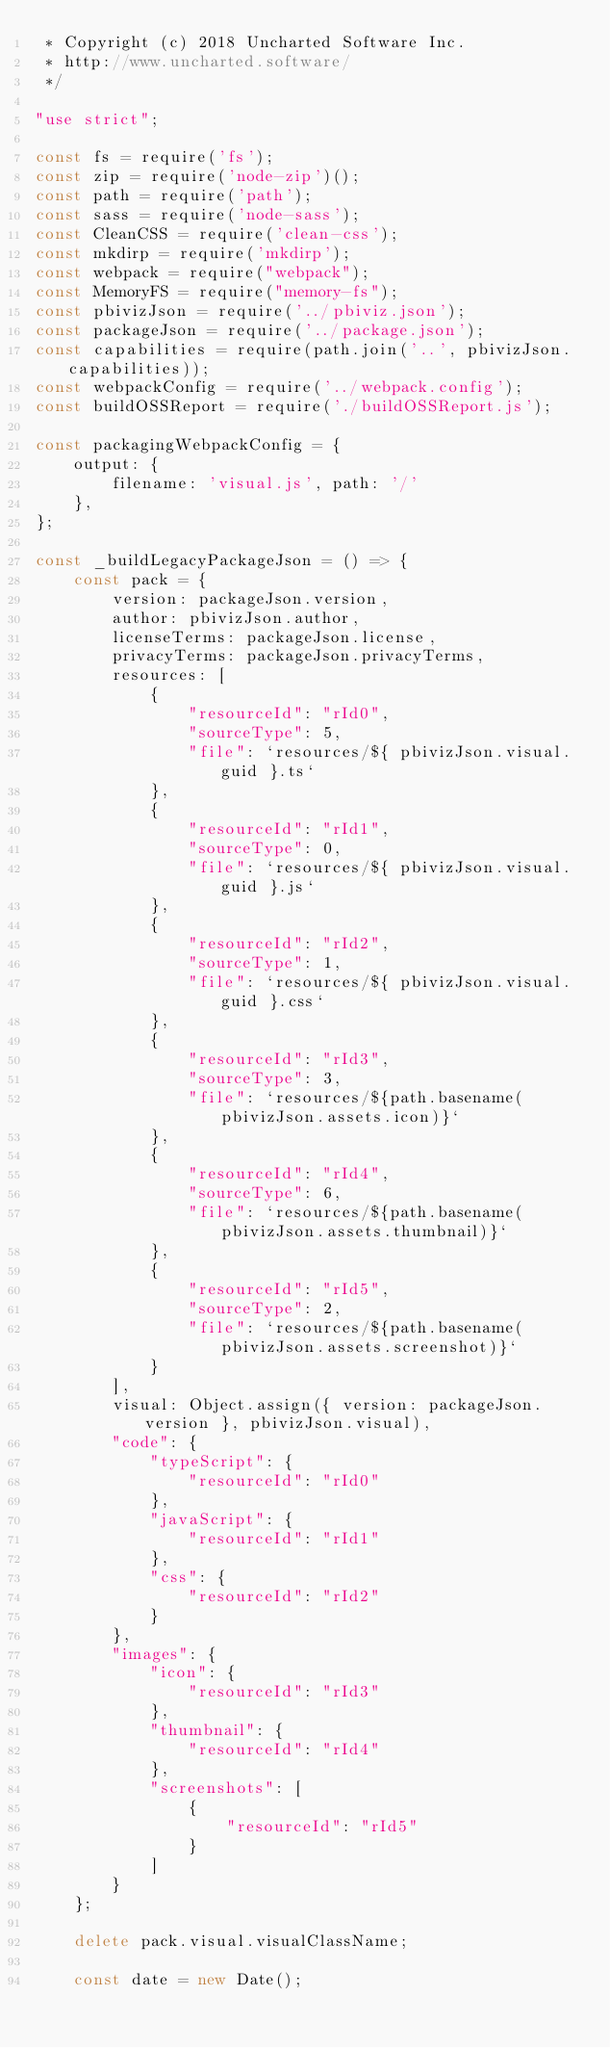<code> <loc_0><loc_0><loc_500><loc_500><_JavaScript_> * Copyright (c) 2018 Uncharted Software Inc.
 * http://www.uncharted.software/
 */

"use strict";

const fs = require('fs');
const zip = require('node-zip')();
const path = require('path');
const sass = require('node-sass');
const CleanCSS = require('clean-css');
const mkdirp = require('mkdirp');
const webpack = require("webpack");
const MemoryFS = require("memory-fs");
const pbivizJson = require('../pbiviz.json');
const packageJson = require('../package.json');
const capabilities = require(path.join('..', pbivizJson.capabilities));
const webpackConfig = require('../webpack.config');
const buildOSSReport = require('./buildOSSReport.js');

const packagingWebpackConfig = {
    output: {
        filename: 'visual.js', path: '/'
    },
};

const _buildLegacyPackageJson = () => {
    const pack = {
        version: packageJson.version,
        author: pbivizJson.author,
        licenseTerms: packageJson.license,
        privacyTerms: packageJson.privacyTerms,
        resources: [
            {
                "resourceId": "rId0",
                "sourceType": 5,
                "file": `resources/${ pbivizJson.visual.guid }.ts`
            },
            {
                "resourceId": "rId1",
                "sourceType": 0,
                "file": `resources/${ pbivizJson.visual.guid }.js`
            },
            {
                "resourceId": "rId2",
                "sourceType": 1,
                "file": `resources/${ pbivizJson.visual.guid }.css`
            },
            {
                "resourceId": "rId3",
                "sourceType": 3,
                "file": `resources/${path.basename(pbivizJson.assets.icon)}`
            },
            {
                "resourceId": "rId4",
                "sourceType": 6,
                "file": `resources/${path.basename(pbivizJson.assets.thumbnail)}`
            },
            {
                "resourceId": "rId5",
                "sourceType": 2,
                "file": `resources/${path.basename(pbivizJson.assets.screenshot)}`
            }
        ],
        visual: Object.assign({ version: packageJson.version }, pbivizJson.visual),
        "code": {
            "typeScript": {
                "resourceId": "rId0"
            },
            "javaScript": {
                "resourceId": "rId1"
            },
            "css": {
                "resourceId": "rId2"
            }
        },
        "images": {
            "icon": {
                "resourceId": "rId3"
            },
            "thumbnail": {
                "resourceId": "rId4"
            },
            "screenshots": [
                {
                    "resourceId": "rId5"
                }
            ]
        }
    };

    delete pack.visual.visualClassName;

    const date = new Date();</code> 